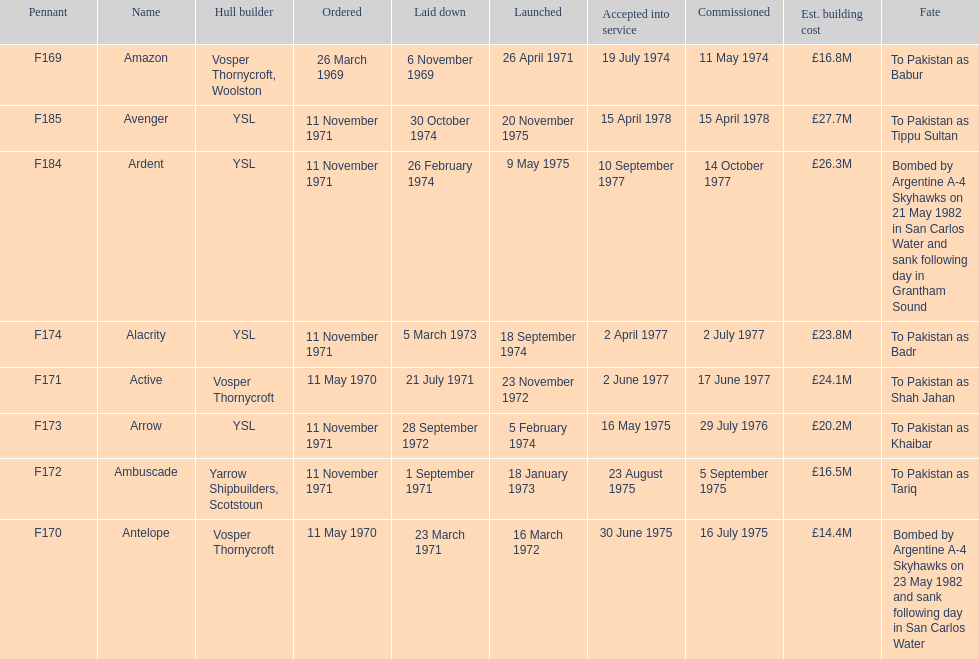Amazon is at the top of the chart, but what is the name below it? Antelope. 